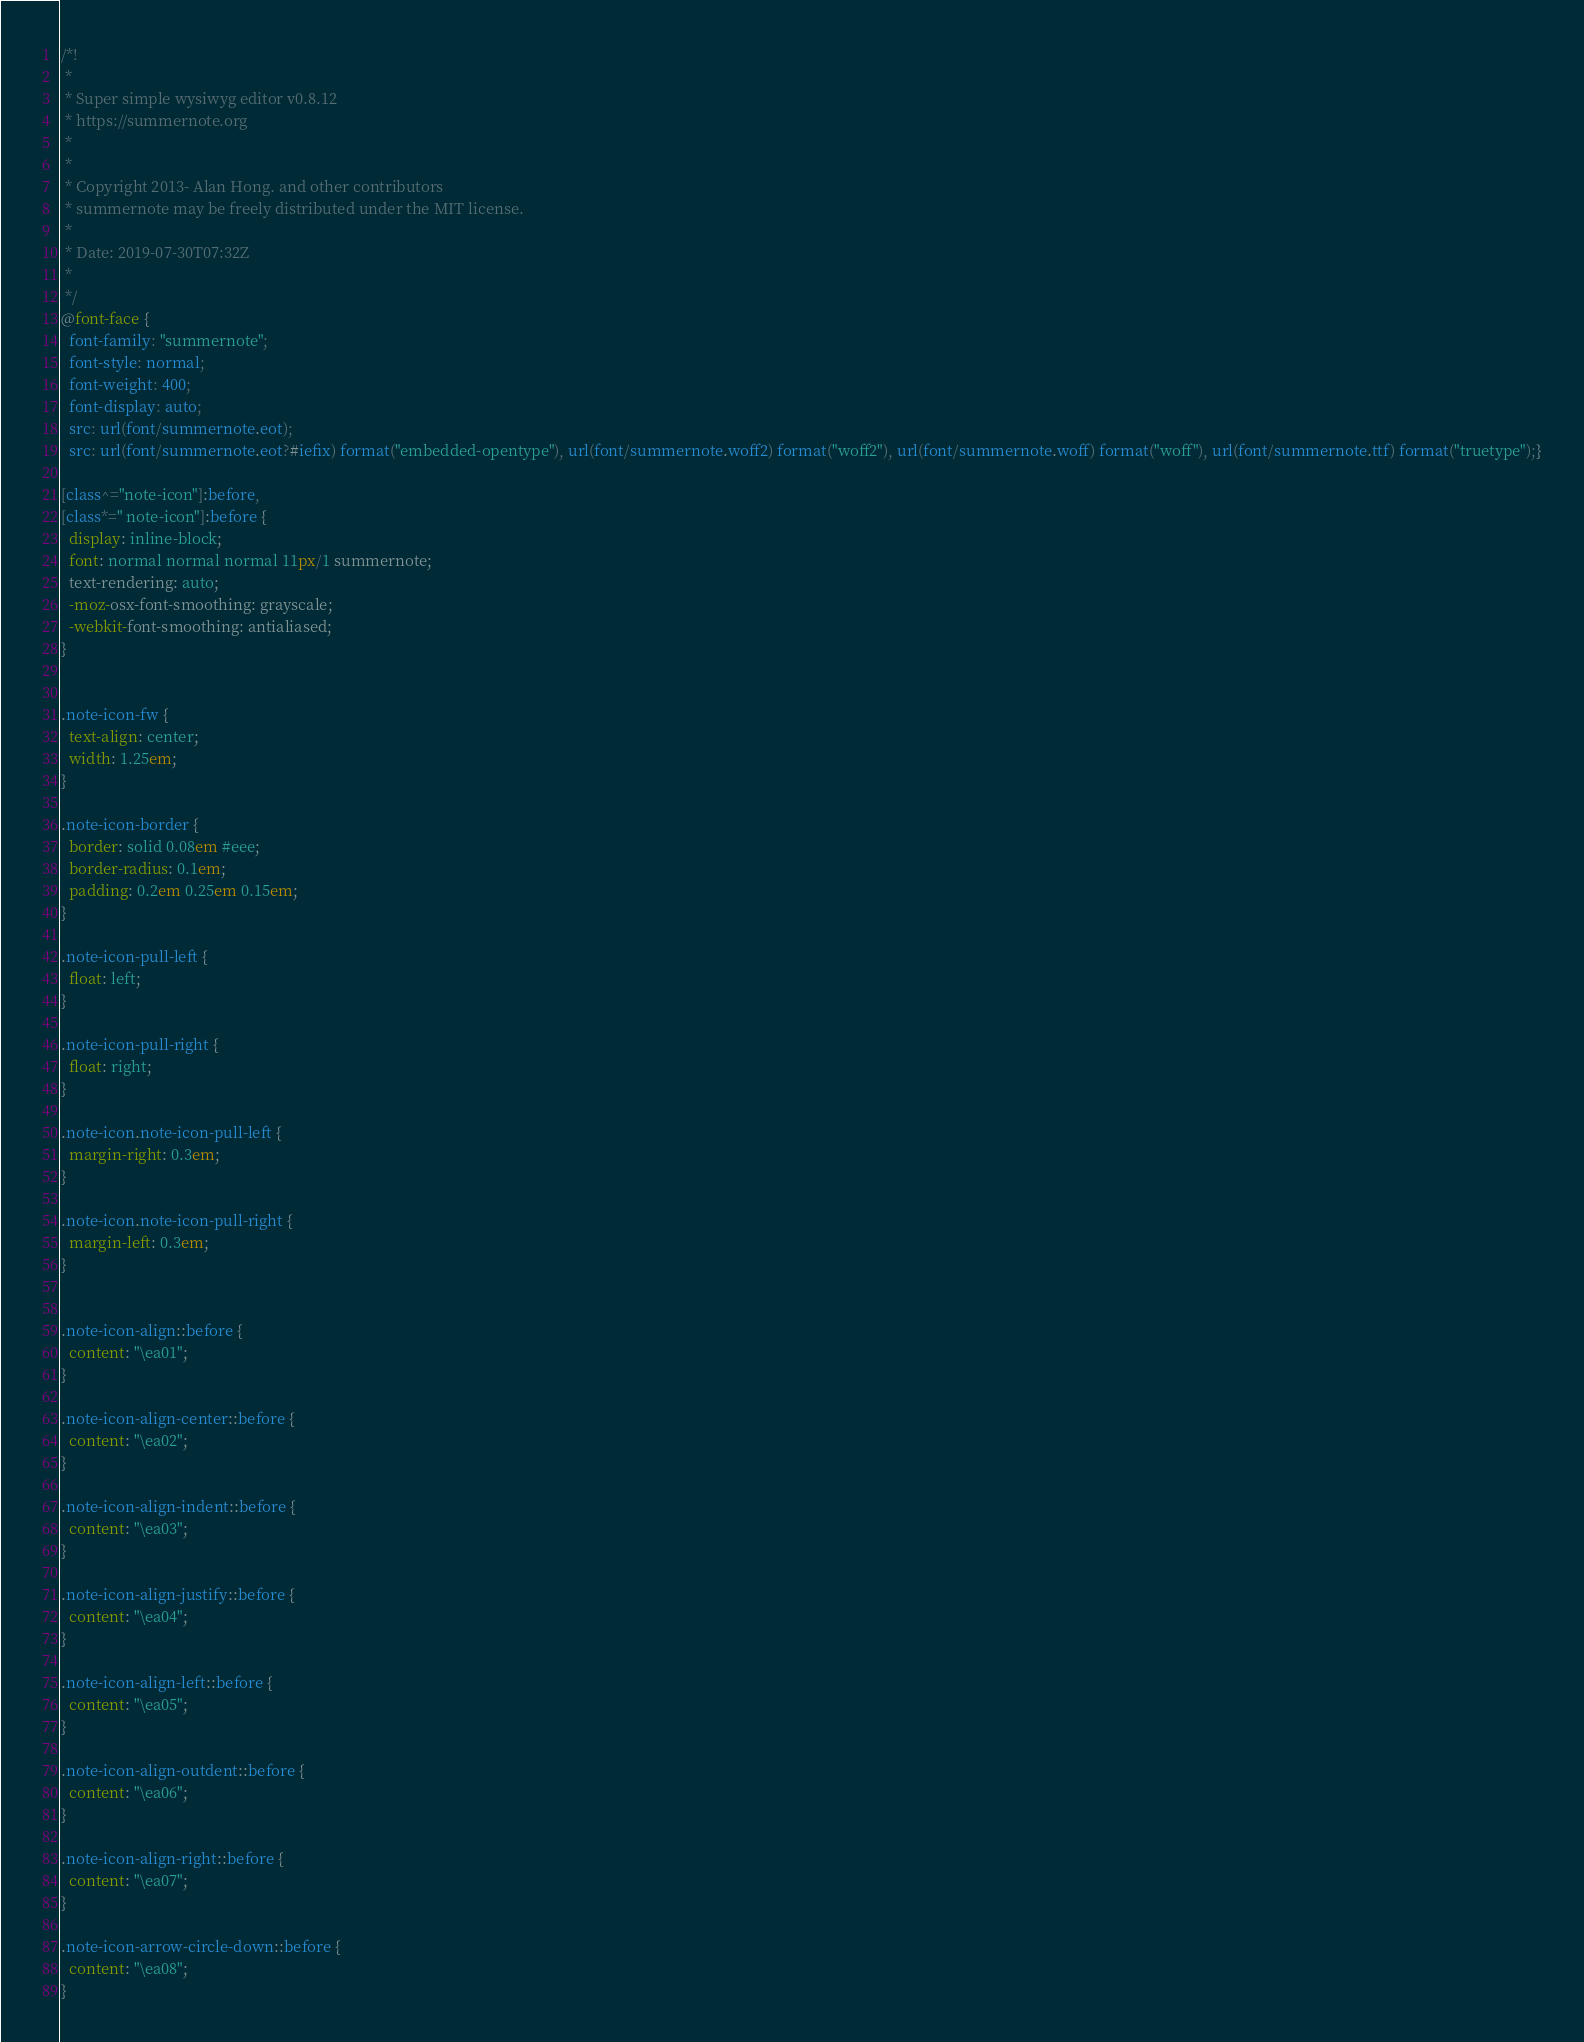<code> <loc_0><loc_0><loc_500><loc_500><_CSS_>/*!
 * 
 * Super simple wysiwyg editor v0.8.12
 * https://summernote.org
 * 
 * 
 * Copyright 2013- Alan Hong. and other contributors
 * summernote may be freely distributed under the MIT license.
 * 
 * Date: 2019-07-30T07:32Z
 * 
 */
@font-face {
  font-family: "summernote";
  font-style: normal;
  font-weight: 400;
  font-display: auto;
  src: url(font/summernote.eot);
  src: url(font/summernote.eot?#iefix) format("embedded-opentype"), url(font/summernote.woff2) format("woff2"), url(font/summernote.woff) format("woff"), url(font/summernote.ttf) format("truetype");}

[class^="note-icon"]:before,
[class*=" note-icon"]:before {
  display: inline-block;
  font: normal normal normal 11px/1 summernote;
  text-rendering: auto;
  -moz-osx-font-smoothing: grayscale;
  -webkit-font-smoothing: antialiased;
}
 

.note-icon-fw {
  text-align: center;
  width: 1.25em;
}

.note-icon-border {
  border: solid 0.08em #eee;
  border-radius: 0.1em;
  padding: 0.2em 0.25em 0.15em;
}

.note-icon-pull-left {
  float: left;
}

.note-icon-pull-right {
  float: right;
}

.note-icon.note-icon-pull-left {
  margin-right: 0.3em;
}

.note-icon.note-icon-pull-right {
  margin-left: 0.3em;
}


.note-icon-align::before {
  content: "\ea01";
}

.note-icon-align-center::before {
  content: "\ea02";
}

.note-icon-align-indent::before {
  content: "\ea03";
}

.note-icon-align-justify::before {
  content: "\ea04";
}

.note-icon-align-left::before {
  content: "\ea05";
}

.note-icon-align-outdent::before {
  content: "\ea06";
}

.note-icon-align-right::before {
  content: "\ea07";
}

.note-icon-arrow-circle-down::before {
  content: "\ea08";
}
</code> 